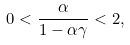Convert formula to latex. <formula><loc_0><loc_0><loc_500><loc_500>0 < \frac { \alpha } { 1 - \alpha \gamma } < 2 ,</formula> 